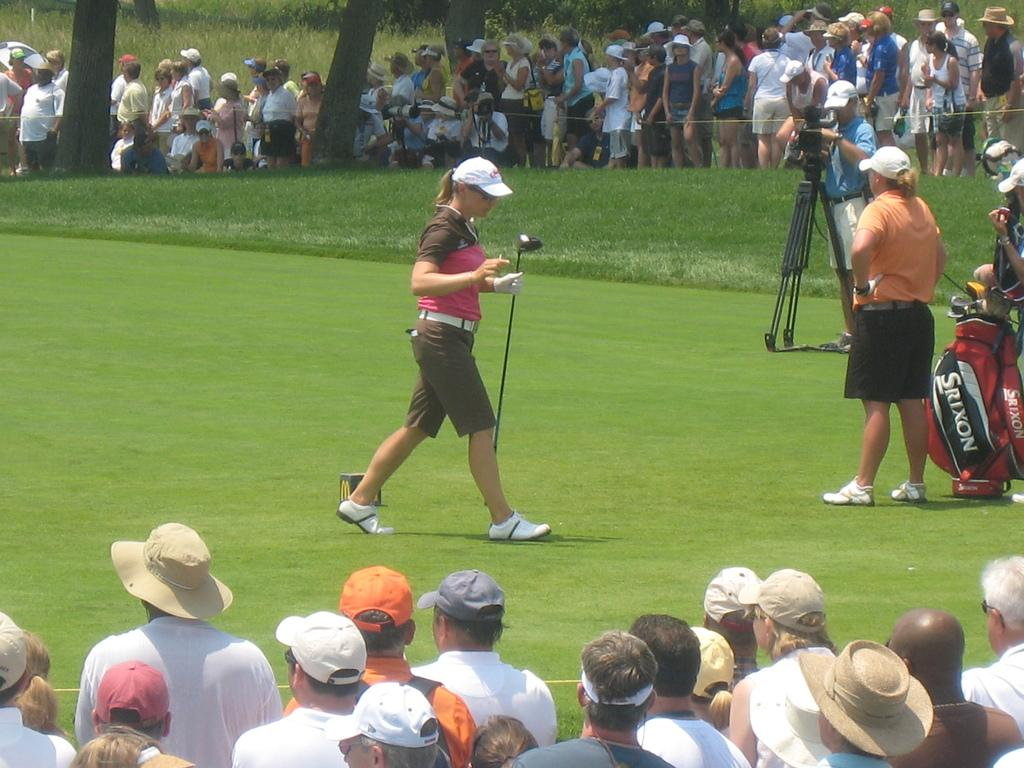<image>
Render a clear and concise summary of the photo. The golfer's red golf club bag is Srixon brand.. 